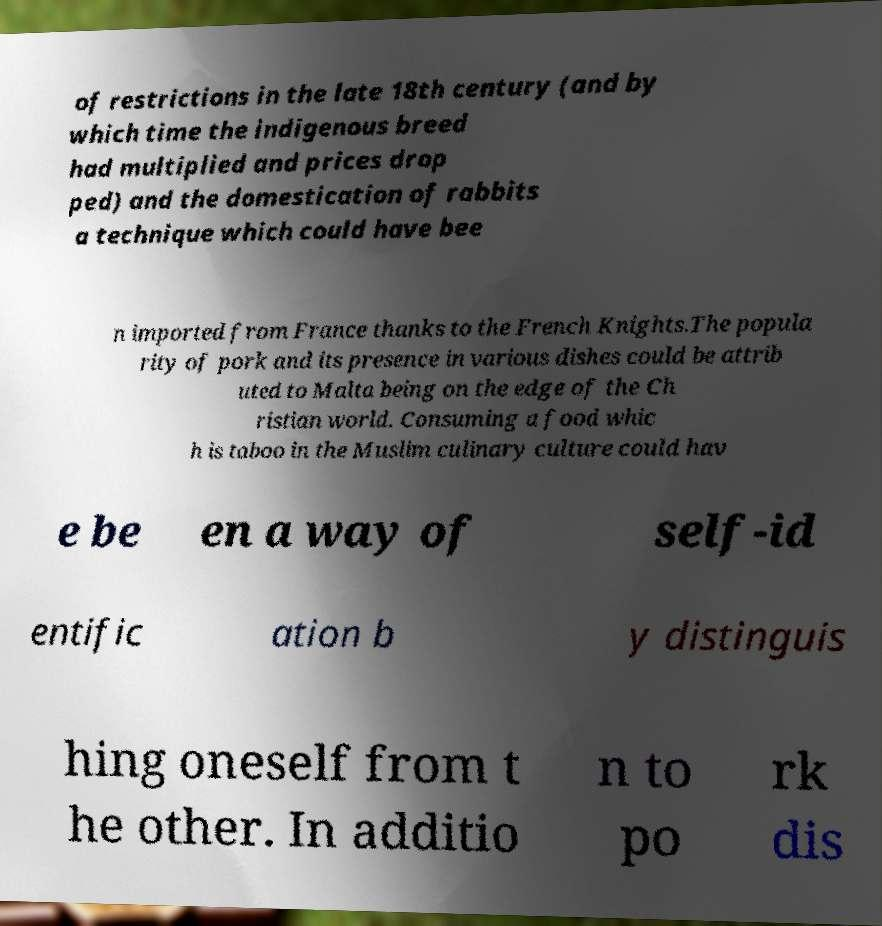I need the written content from this picture converted into text. Can you do that? of restrictions in the late 18th century (and by which time the indigenous breed had multiplied and prices drop ped) and the domestication of rabbits a technique which could have bee n imported from France thanks to the French Knights.The popula rity of pork and its presence in various dishes could be attrib uted to Malta being on the edge of the Ch ristian world. Consuming a food whic h is taboo in the Muslim culinary culture could hav e be en a way of self-id entific ation b y distinguis hing oneself from t he other. In additio n to po rk dis 